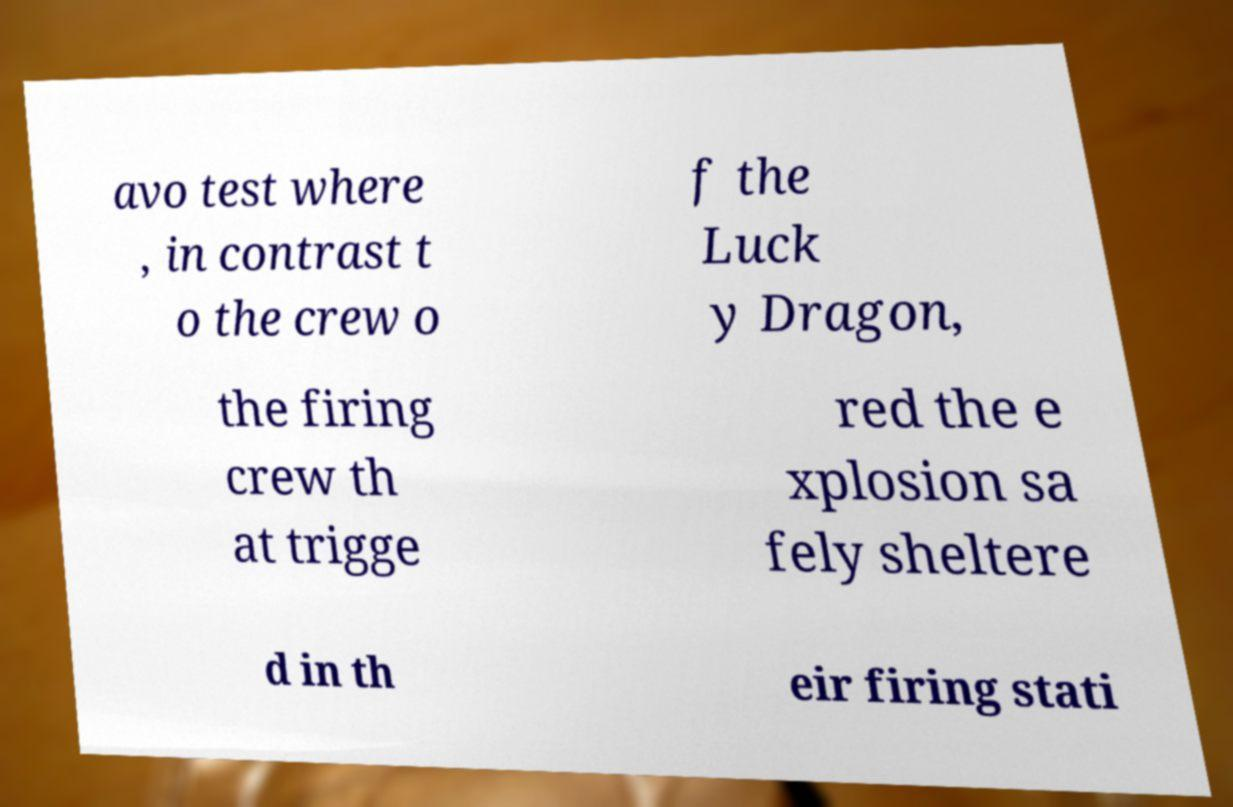Could you assist in decoding the text presented in this image and type it out clearly? avo test where , in contrast t o the crew o f the Luck y Dragon, the firing crew th at trigge red the e xplosion sa fely sheltere d in th eir firing stati 